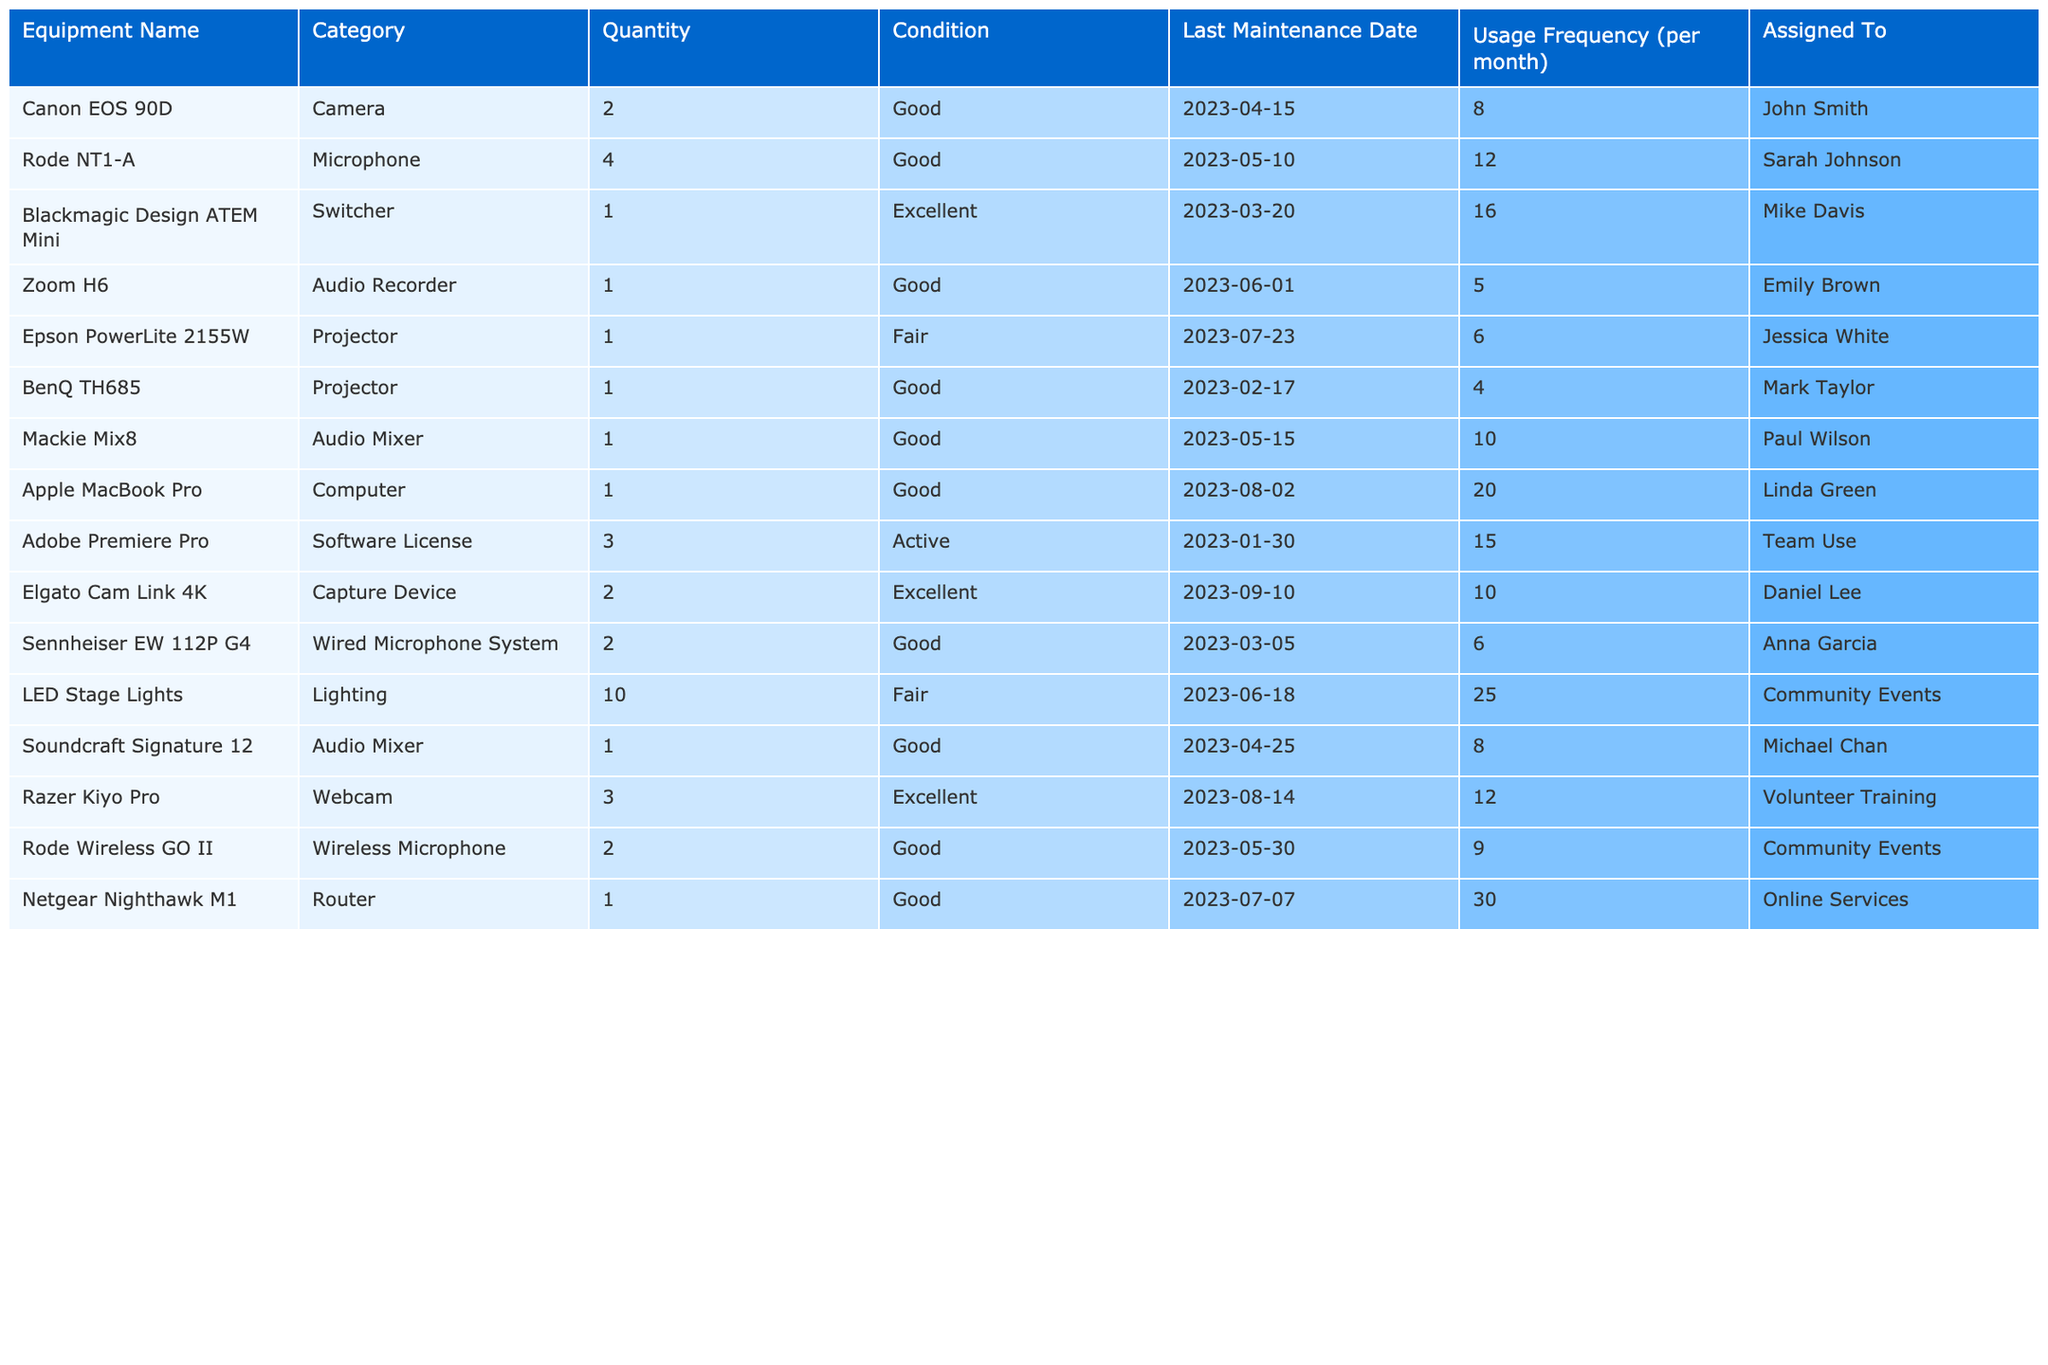What is the total quantity of cameras listed? There are two camera models: Canon EOS 90D with a quantity of 2 and no other cameras listed. Thus, the total quantity is 2.
Answer: 2 Which equipment has the highest usage frequency per month? The Netgear Nighthawk M1 Router has a usage frequency of 30 per month, which is the highest frequency among all equipment listed.
Answer: Netgear Nighthawk M1 How many projectors are in the inventory? There are two projectors listed: Epson PowerLite 2155W and BenQ TH685. Thus, the total number of projectors is 2.
Answer: 2 What is the condition of the Rode NT1-A microphone? The Rode NT1-A microphone is listed as being in "Good" condition.
Answer: Good What is the average usage frequency of the microphones in the inventory? The Rode NT1-A has a frequency of 12, and the Sennheiser EW 112P G4 has a frequency of 6. The average is calculated by (12 + 6) / 2 = 9.
Answer: 9 Is there any equipment assigned to Jessica White? Yes, the Epson PowerLite 2155W projector is assigned to Jessica White.
Answer: Yes What percentage of the equipment is in "Good" condition? There are 10 items listed in total, 6 of which are in "Good" condition. The percentage is (6/10) * 100 = 60%.
Answer: 60% Which equipment has the lowest usage frequency? Zoom H6 Audio Recorder has the lowest usage frequency at 5 per month.
Answer: Zoom H6 If the condition of one of the projectors changes to "Poor," how many projectors would still be in either "Good" or "Excellent" condition? Currently, one projector is in "Good" condition (BenQ TH685) and the other is in "Fair" condition (Epson PowerLite 2155W). If we assume the "Fair" remains, that would mean still one remaining in good condition.
Answer: 1 What equipment is assigned to both "Community Events" and "Volunteer Training"? LED Stage Lights are assigned to Community Events, while Razer Kiyo Pro is assigned to Volunteer Training. Therefore, none of the equipment is assigned to both.
Answer: None 